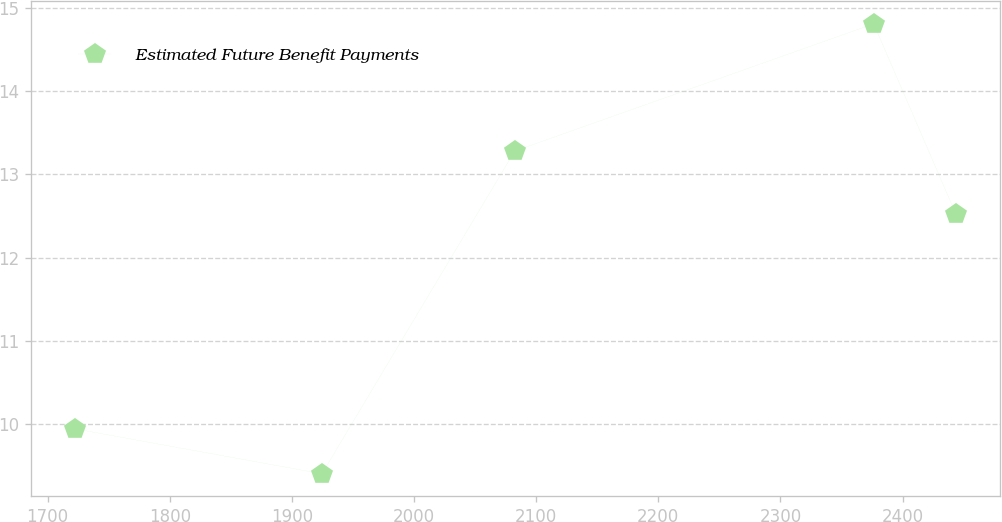Convert chart. <chart><loc_0><loc_0><loc_500><loc_500><line_chart><ecel><fcel>Estimated Future Benefit Payments<nl><fcel>1722.57<fcel>9.94<nl><fcel>1924.59<fcel>9.4<nl><fcel>2082.46<fcel>13.28<nl><fcel>2376.42<fcel>14.81<nl><fcel>2443.76<fcel>12.52<nl></chart> 